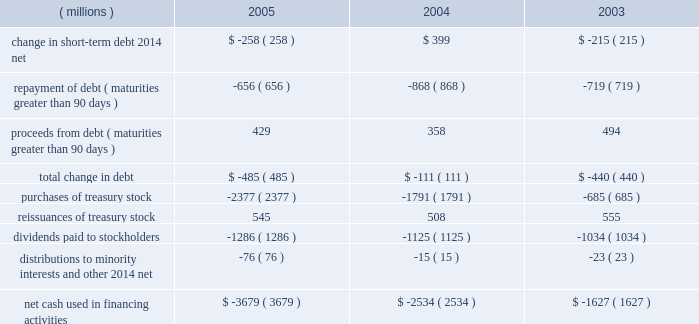Growth focused .
For example , in december 2005 , 3m announced its intention to build an lcd optical film manufacturing facility in poland to support the fast-growing lcd-tv market in europe and to better serve its customers .
The company expects 2006 capital expenditures to total approximately $ 1.1 billion , compared with $ 943 million in 2005 .
In the third quarter of 2005 , 3m completed the acquisition of cuno .
3m acquired cuno for approximately $ 1.36 billion , including assumption of debt .
This $ 1.36 billion included $ 1.27 billion of cash paid ( net of cash acquired ) and the assumption of $ 80 million of debt , most of which has been repaid .
In 2005 , the company also entered into two additional business combinations for a total purchase price of $ 27 million .
Refer to note 2 to the consolidated financial statements for more information on these 2005 business combinations , and for information concerning 2004 and 2003 business combinations .
Purchases of investments in 2005 include the purchase from ti&m beteiligungsgesellschaft mbh of 19 percent of i&t innovation technology ( discussed previously under the transportation business segment ) .
The purchase price of approximately $ 55 million is reported as 201cinvestments 201d in the consolidated balance sheet and as 201cpurchases of investments 201d in the consolidated statement of cash flows .
Other 201cpurchases of investments 201d and 201cproceeds from sale of investments 201d in 2005 are primarily attributable to auction rate securities , which are classified as available-for-sale .
Prior to 2005 , purchases of and proceeds from the sale of auction rate securities were classified as cash and cash equivalents .
At december 31 , 2004 , the amount of such securities taken as a whole was immaterial to cash and cash equivalents , and accordingly were not reclassified for 2004 and prior .
Proceeds from the sale of investments in 2003 include $ 26 million of cash received related to the sale of 3m 2019s 50% ( 50 % ) ownership in durel corporation to rogers corporation .
Additional purchases of investments totaled $ 5 million in 2005 , $ 10 million in 2004 and $ 16 million in 2003 .
These purchases include additional survivor benefit insurance and equity investments .
The company is actively considering additional acquisitions , investments and strategic alliances .
Cash flows from financing activities : years ended december 31 .
Total debt at december 31 , 2005 , was $ 2.381 billion , down from $ 2.821 billion at year-end 2004 , with the decrease primarily attributable to the retirement of $ 400 million in medium-term notes .
There were no new long- term debt issuances in 2005 .
In 2005 , the cash flow decrease in net short-term debt of $ 258 million includes the portion of short-term debt with original maturities of 90 days or less .
The repayment of debt of $ 656 million primarily related to the retirement of $ 400 million in medium-term notes and commercial paper retirements .
Proceeds from debt of $ 429 million primarily related to commercial paper issuances .
Total debt was 19% ( 19 % ) of total capital ( total capital is defined as debt plus equity ) , compared with 21% ( 21 % ) at year-end 2004 .
Debt securities , including the company 2019s shelf registration , its medium-term notes program , dealer remarketable securities and convertible note , are all discussed in more detail in note 8 to the consolidated financial statements .
3m has a shelf registration and medium-term notes program through which $ 1.5 billion of medium- term notes may be offered .
In 2004 , the company issued approximately $ 62 million in debt securities under its medium-term notes program .
No debt was issued under this program in 2005 .
The medium-term notes program and shelf registration have remaining capacity of approximately $ 1.438 billion .
The company 2019s $ 350 million of dealer remarketable securities ( classified as current portion of long-term debt ) were remarketed for one year in december 2005 .
In addition , the company has convertible notes with a book value of $ 539 million at december 31 , 2005 .
The next put option date for these convertible notes is november 2007 , thus at year-end 2005 this debt .
What was the percentage change in the net cash used in financing activities from 2004 to 2005? 
Rationale: the net cash used in financing activities increased by 45.2% from 2004 to 2005
Computations: ((3679 - 2534) / 2534)
Answer: 0.45185. 